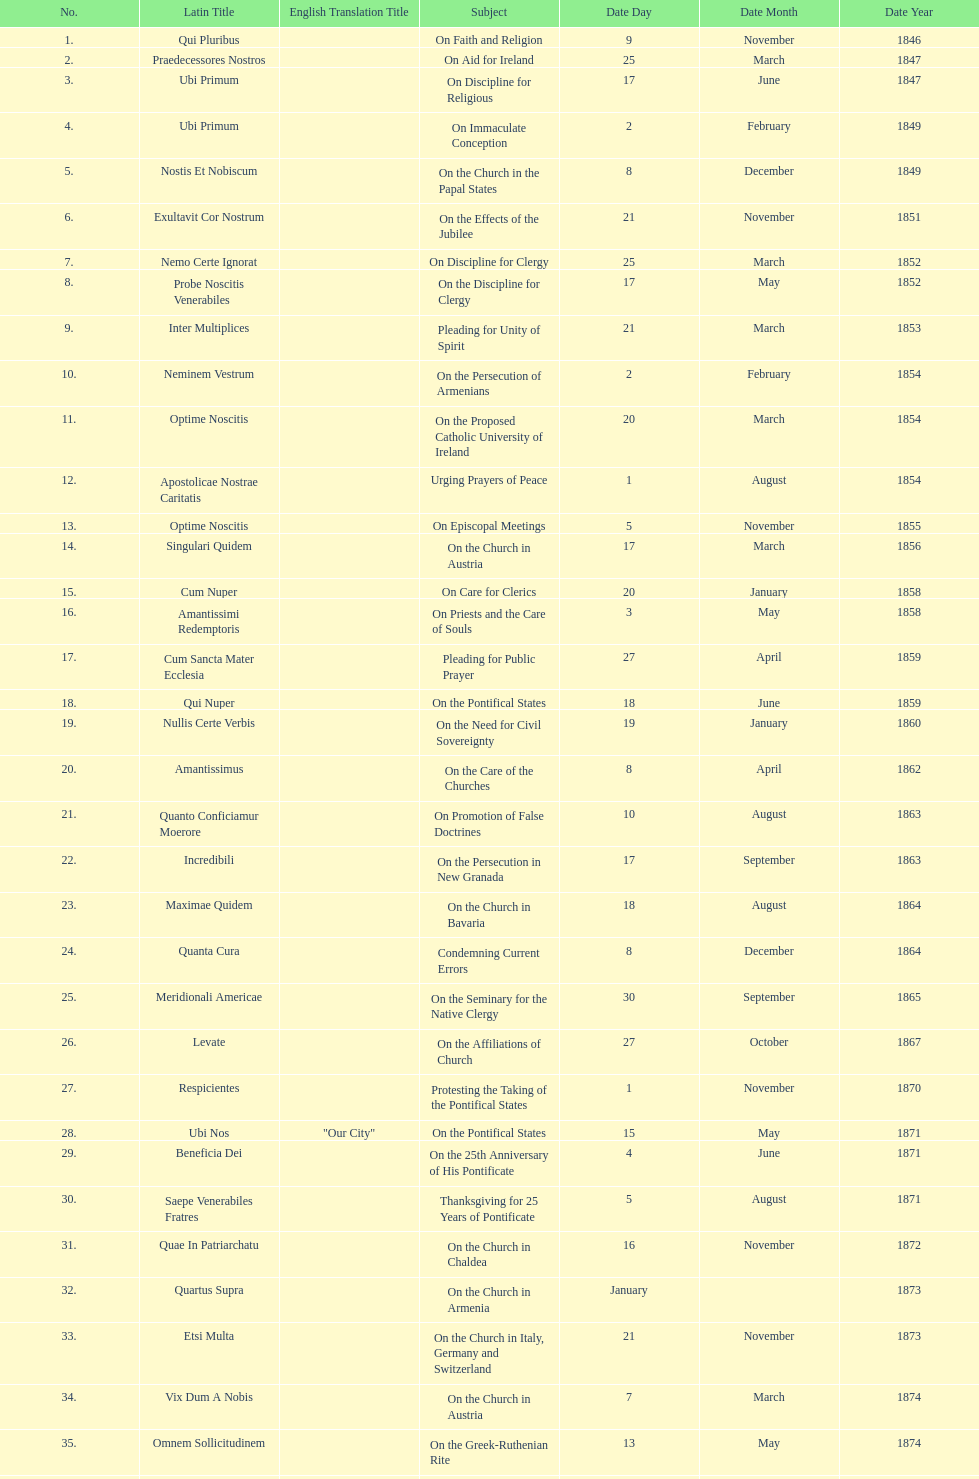How often was an encyclical sent in january? 3. 